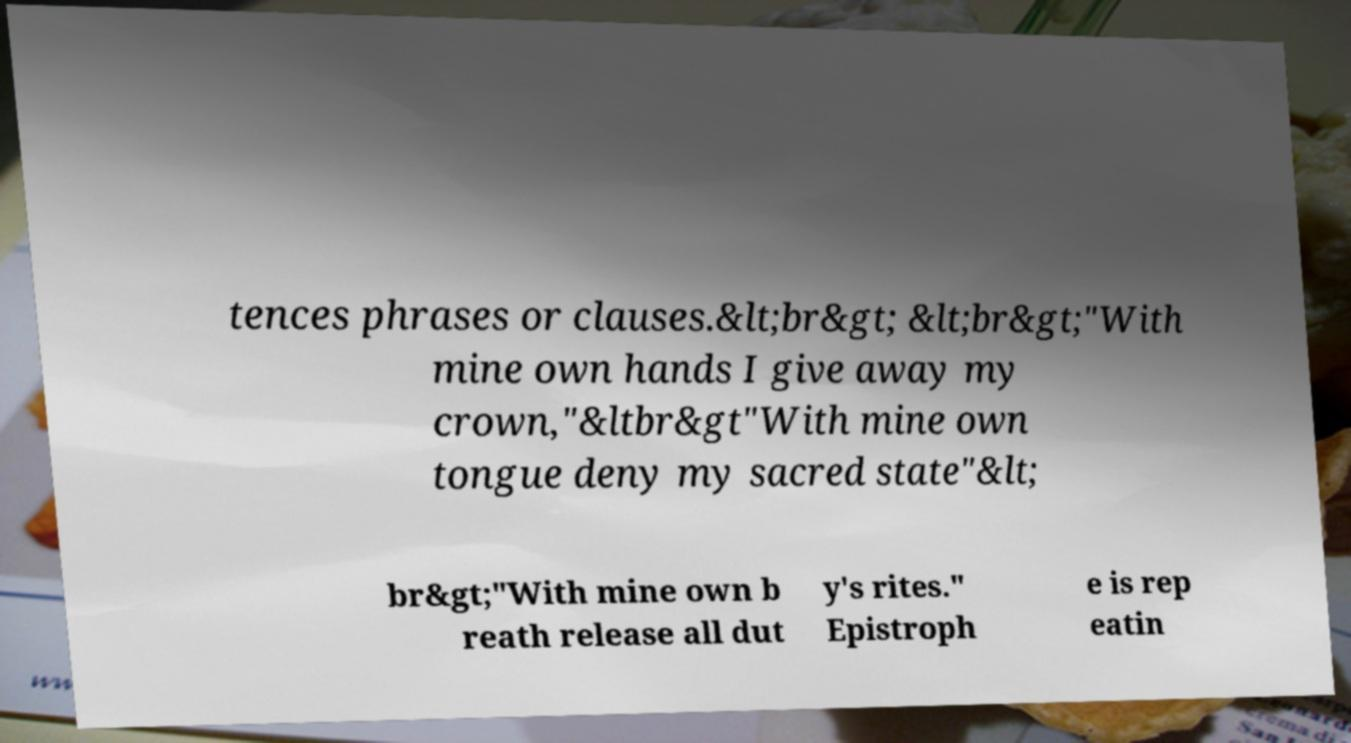Please read and relay the text visible in this image. What does it say? tences phrases or clauses.&lt;br&gt; &lt;br&gt;"With mine own hands I give away my crown,"&ltbr&gt"With mine own tongue deny my sacred state"&lt; br&gt;"With mine own b reath release all dut y's rites." Epistroph e is rep eatin 